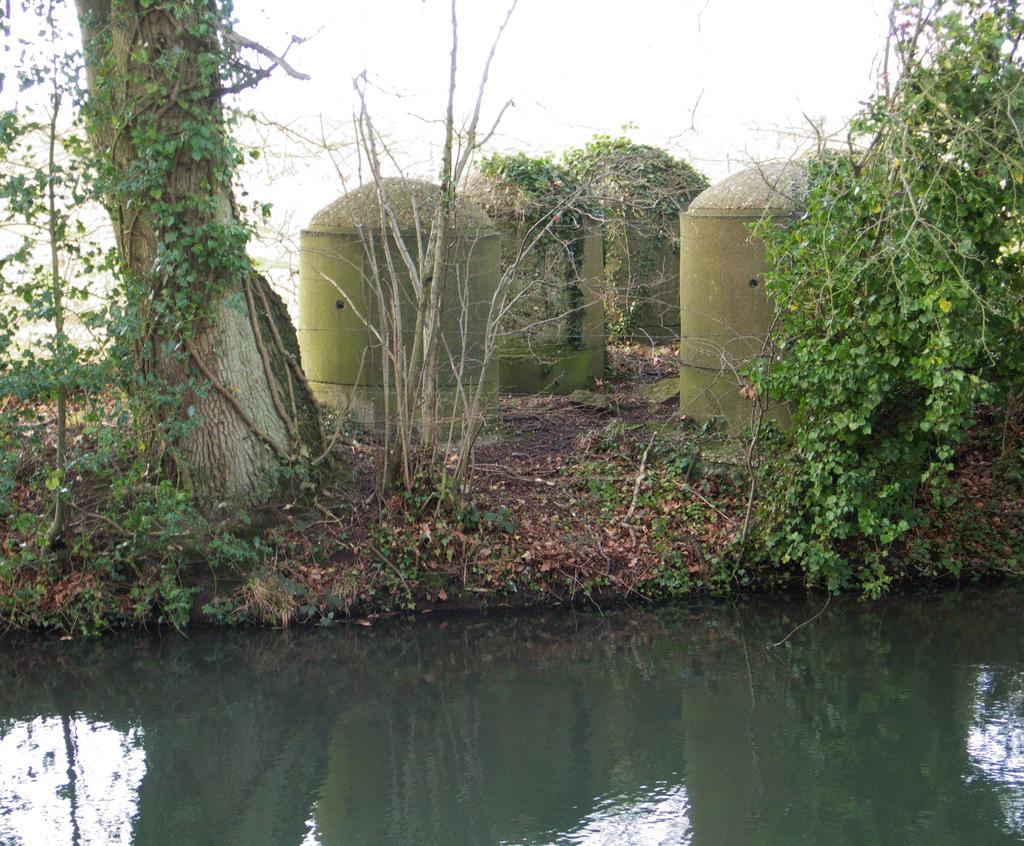What structures are located in the center of the image? There are pillars in the center of the image. What type of vegetation can be seen in the image? There are trees in the image. What is at the bottom of the image? There is water at the bottom of the image. What is visible in the background of the image? The sky is visible in the background of the image. What type of shock can be seen in the image? There is no shock present in the image. Is there a street visible in the image? There is no street visible in the image. 